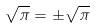Convert formula to latex. <formula><loc_0><loc_0><loc_500><loc_500>\sqrt { \pi } = \pm \sqrt { \pi }</formula> 